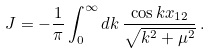Convert formula to latex. <formula><loc_0><loc_0><loc_500><loc_500>J = - \frac { 1 } { \pi } \int _ { 0 } ^ { \infty } d k \, \frac { \cos k x _ { 1 2 } } { \sqrt { k ^ { 2 } + \mu ^ { 2 } } } \, .</formula> 